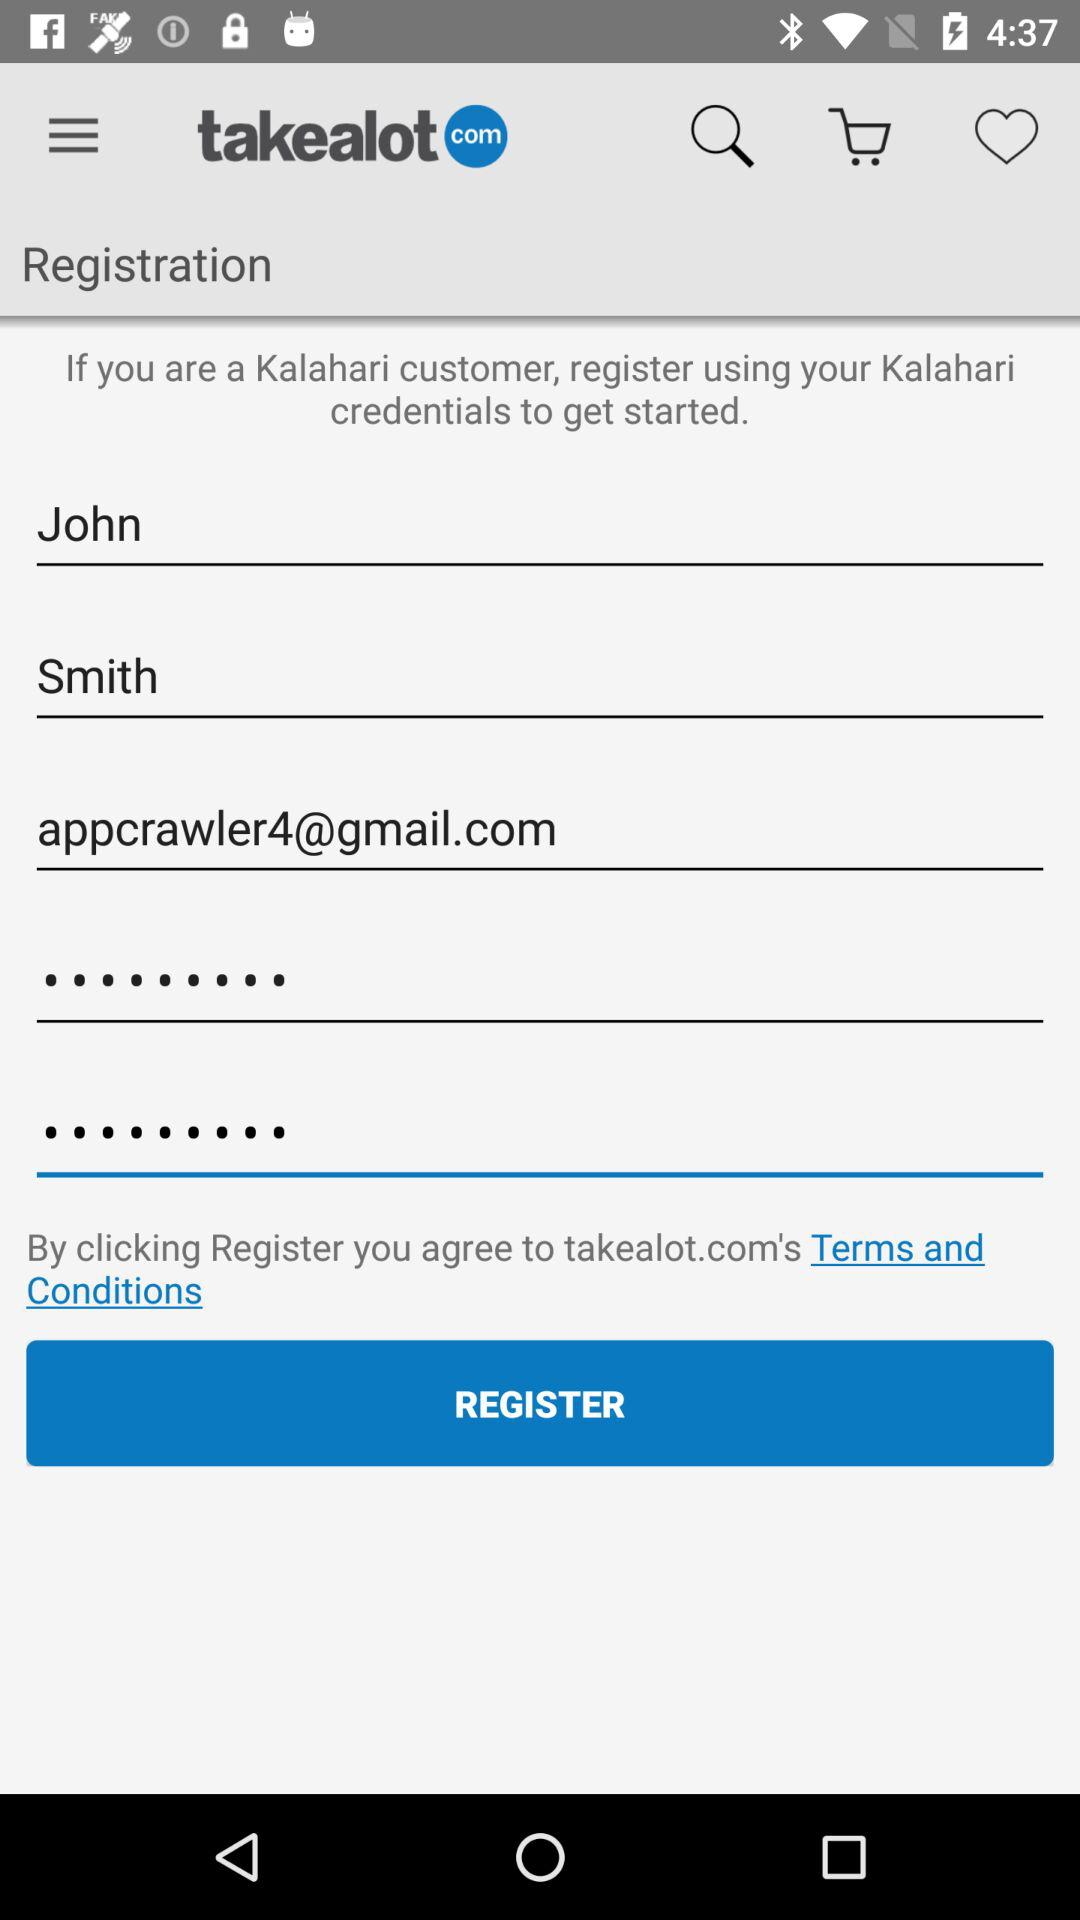What credentials can be used for registration? Registration can be done using "Kalahari" credentials. 